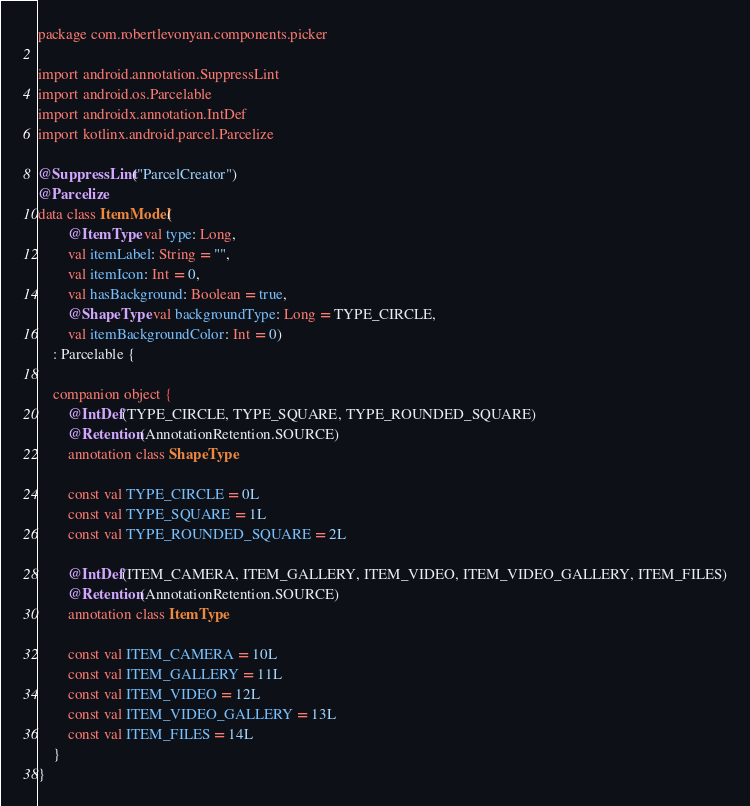<code> <loc_0><loc_0><loc_500><loc_500><_Kotlin_>package com.robertlevonyan.components.picker

import android.annotation.SuppressLint
import android.os.Parcelable
import androidx.annotation.IntDef
import kotlinx.android.parcel.Parcelize

@SuppressLint("ParcelCreator")
@Parcelize
data class ItemModel(
        @ItemType val type: Long,
        val itemLabel: String = "",
        val itemIcon: Int = 0,
        val hasBackground: Boolean = true,
        @ShapeType val backgroundType: Long = TYPE_CIRCLE,
        val itemBackgroundColor: Int = 0)
    : Parcelable {

    companion object {
        @IntDef(TYPE_CIRCLE, TYPE_SQUARE, TYPE_ROUNDED_SQUARE)
        @Retention(AnnotationRetention.SOURCE)
        annotation class ShapeType

        const val TYPE_CIRCLE = 0L
        const val TYPE_SQUARE = 1L
        const val TYPE_ROUNDED_SQUARE = 2L

        @IntDef(ITEM_CAMERA, ITEM_GALLERY, ITEM_VIDEO, ITEM_VIDEO_GALLERY, ITEM_FILES)
        @Retention(AnnotationRetention.SOURCE)
        annotation class ItemType

        const val ITEM_CAMERA = 10L
        const val ITEM_GALLERY = 11L
        const val ITEM_VIDEO = 12L
        const val ITEM_VIDEO_GALLERY = 13L
        const val ITEM_FILES = 14L
    }
}</code> 